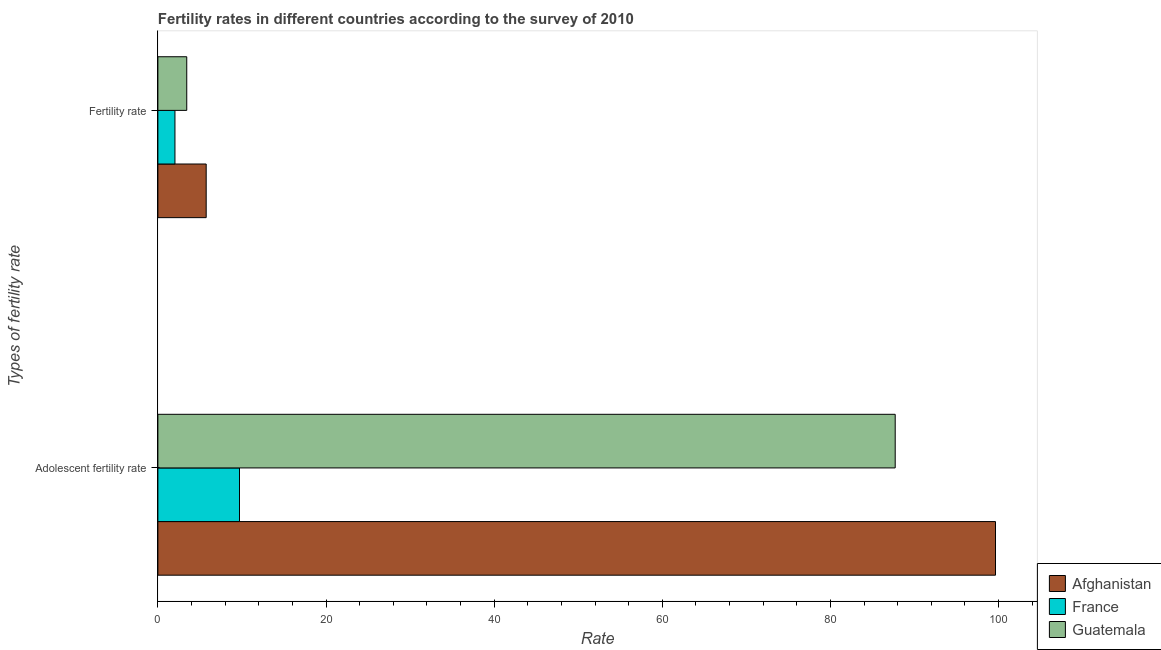How many different coloured bars are there?
Your response must be concise. 3. Are the number of bars per tick equal to the number of legend labels?
Your answer should be very brief. Yes. Are the number of bars on each tick of the Y-axis equal?
Provide a succinct answer. Yes. How many bars are there on the 2nd tick from the top?
Your answer should be compact. 3. How many bars are there on the 2nd tick from the bottom?
Your answer should be very brief. 3. What is the label of the 1st group of bars from the top?
Offer a very short reply. Fertility rate. What is the fertility rate in Guatemala?
Keep it short and to the point. 3.43. Across all countries, what is the maximum fertility rate?
Provide a succinct answer. 5.75. Across all countries, what is the minimum fertility rate?
Your response must be concise. 2.03. In which country was the fertility rate maximum?
Offer a very short reply. Afghanistan. What is the total fertility rate in the graph?
Give a very brief answer. 11.21. What is the difference between the adolescent fertility rate in Afghanistan and that in Guatemala?
Keep it short and to the point. 11.93. What is the difference between the fertility rate in France and the adolescent fertility rate in Guatemala?
Your response must be concise. -85.67. What is the average adolescent fertility rate per country?
Give a very brief answer. 65.68. What is the difference between the adolescent fertility rate and fertility rate in Afghanistan?
Your answer should be compact. 93.89. In how many countries, is the adolescent fertility rate greater than 76 ?
Keep it short and to the point. 2. What is the ratio of the fertility rate in France to that in Guatemala?
Make the answer very short. 0.59. In how many countries, is the fertility rate greater than the average fertility rate taken over all countries?
Your response must be concise. 1. How many bars are there?
Offer a very short reply. 6. Are all the bars in the graph horizontal?
Keep it short and to the point. Yes. How many countries are there in the graph?
Your response must be concise. 3. What is the difference between two consecutive major ticks on the X-axis?
Keep it short and to the point. 20. Does the graph contain any zero values?
Ensure brevity in your answer.  No. Does the graph contain grids?
Ensure brevity in your answer.  No. Where does the legend appear in the graph?
Keep it short and to the point. Bottom right. How are the legend labels stacked?
Your answer should be very brief. Vertical. What is the title of the graph?
Provide a short and direct response. Fertility rates in different countries according to the survey of 2010. What is the label or title of the X-axis?
Your answer should be compact. Rate. What is the label or title of the Y-axis?
Provide a succinct answer. Types of fertility rate. What is the Rate of Afghanistan in Adolescent fertility rate?
Your response must be concise. 99.63. What is the Rate of France in Adolescent fertility rate?
Ensure brevity in your answer.  9.71. What is the Rate of Guatemala in Adolescent fertility rate?
Make the answer very short. 87.7. What is the Rate in Afghanistan in Fertility rate?
Give a very brief answer. 5.75. What is the Rate of France in Fertility rate?
Your answer should be very brief. 2.03. What is the Rate of Guatemala in Fertility rate?
Your answer should be very brief. 3.43. Across all Types of fertility rate, what is the maximum Rate of Afghanistan?
Provide a succinct answer. 99.63. Across all Types of fertility rate, what is the maximum Rate of France?
Your answer should be compact. 9.71. Across all Types of fertility rate, what is the maximum Rate in Guatemala?
Ensure brevity in your answer.  87.7. Across all Types of fertility rate, what is the minimum Rate of Afghanistan?
Offer a terse response. 5.75. Across all Types of fertility rate, what is the minimum Rate in France?
Your response must be concise. 2.03. Across all Types of fertility rate, what is the minimum Rate of Guatemala?
Keep it short and to the point. 3.43. What is the total Rate of Afghanistan in the graph?
Your response must be concise. 105.38. What is the total Rate in France in the graph?
Keep it short and to the point. 11.74. What is the total Rate of Guatemala in the graph?
Provide a succinct answer. 91.14. What is the difference between the Rate in Afghanistan in Adolescent fertility rate and that in Fertility rate?
Offer a terse response. 93.89. What is the difference between the Rate in France in Adolescent fertility rate and that in Fertility rate?
Your answer should be compact. 7.68. What is the difference between the Rate of Guatemala in Adolescent fertility rate and that in Fertility rate?
Your answer should be very brief. 84.27. What is the difference between the Rate in Afghanistan in Adolescent fertility rate and the Rate in France in Fertility rate?
Your response must be concise. 97.6. What is the difference between the Rate in Afghanistan in Adolescent fertility rate and the Rate in Guatemala in Fertility rate?
Ensure brevity in your answer.  96.2. What is the difference between the Rate in France in Adolescent fertility rate and the Rate in Guatemala in Fertility rate?
Give a very brief answer. 6.27. What is the average Rate of Afghanistan per Types of fertility rate?
Provide a succinct answer. 52.69. What is the average Rate of France per Types of fertility rate?
Offer a terse response. 5.87. What is the average Rate of Guatemala per Types of fertility rate?
Provide a succinct answer. 45.57. What is the difference between the Rate in Afghanistan and Rate in France in Adolescent fertility rate?
Your answer should be compact. 89.92. What is the difference between the Rate in Afghanistan and Rate in Guatemala in Adolescent fertility rate?
Provide a succinct answer. 11.93. What is the difference between the Rate of France and Rate of Guatemala in Adolescent fertility rate?
Offer a very short reply. -77.99. What is the difference between the Rate in Afghanistan and Rate in France in Fertility rate?
Your answer should be very brief. 3.72. What is the difference between the Rate of Afghanistan and Rate of Guatemala in Fertility rate?
Provide a short and direct response. 2.31. What is the difference between the Rate of France and Rate of Guatemala in Fertility rate?
Give a very brief answer. -1.4. What is the ratio of the Rate in Afghanistan in Adolescent fertility rate to that in Fertility rate?
Give a very brief answer. 17.34. What is the ratio of the Rate in France in Adolescent fertility rate to that in Fertility rate?
Your answer should be compact. 4.78. What is the ratio of the Rate of Guatemala in Adolescent fertility rate to that in Fertility rate?
Your answer should be very brief. 25.54. What is the difference between the highest and the second highest Rate of Afghanistan?
Your answer should be very brief. 93.89. What is the difference between the highest and the second highest Rate in France?
Offer a terse response. 7.68. What is the difference between the highest and the second highest Rate in Guatemala?
Your response must be concise. 84.27. What is the difference between the highest and the lowest Rate in Afghanistan?
Ensure brevity in your answer.  93.89. What is the difference between the highest and the lowest Rate in France?
Your answer should be compact. 7.68. What is the difference between the highest and the lowest Rate in Guatemala?
Keep it short and to the point. 84.27. 